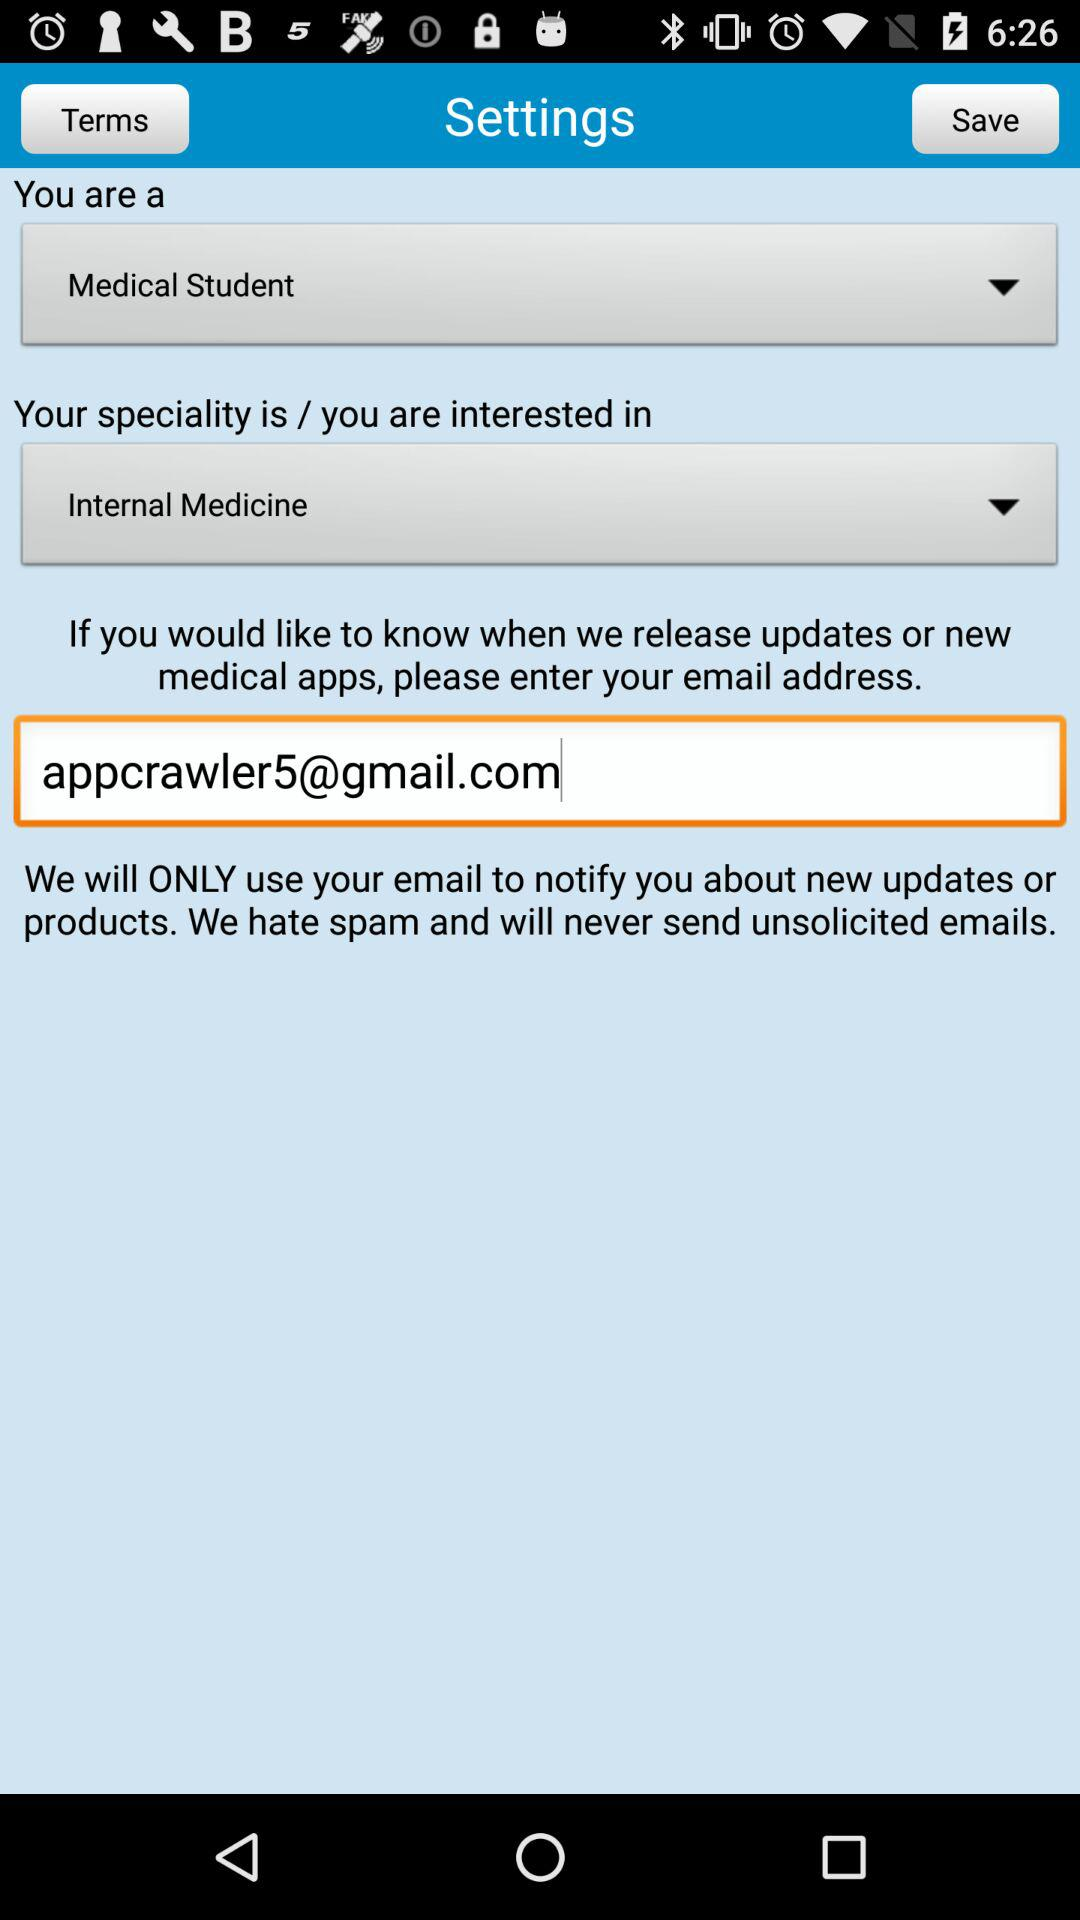What is the email address? The email address is appcrawler5@gmail.com. 